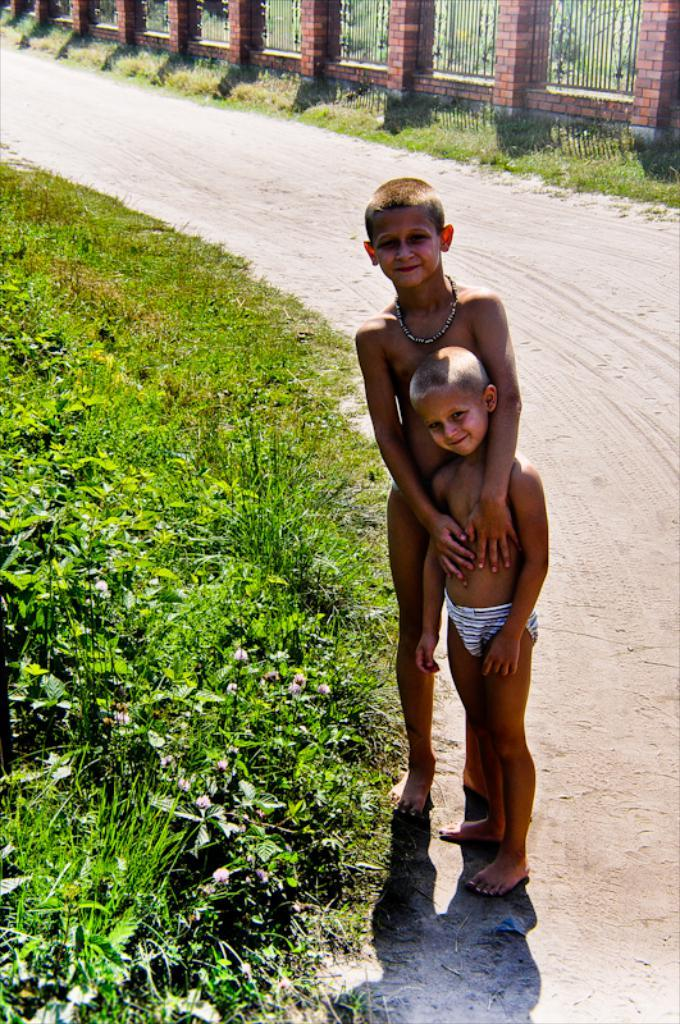What are the main subjects in the image? There are two kids standing on the road in the center of the image. What can be seen on the left side of the image? There is grass on the left side of the image. What is visible in the background of the image? There is fencing in the background of the image. Where is the grandmother in the image? There is no grandmother present in the image. What type of order is being followed by the kids in the image? The image does not provide information about any order being followed by the kids. 